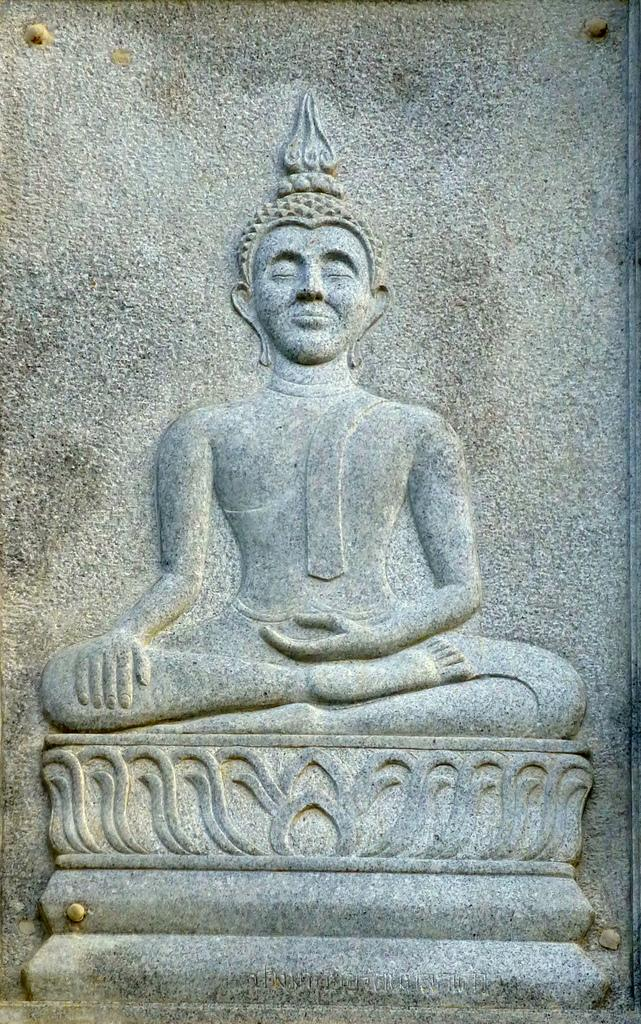What is the main subject of the image? There is a sculpture in the image. What type of glue is used to hold the air together in the sculpture? There is no mention of glue or air in the image, as it only features a sculpture. 